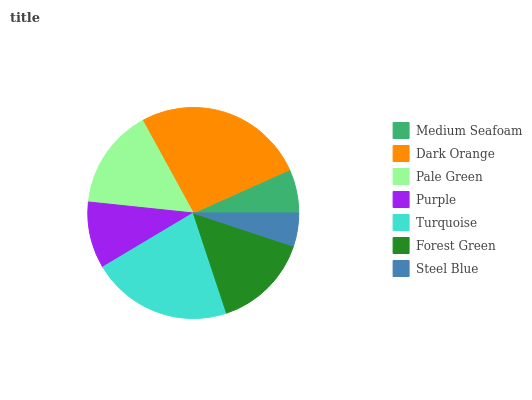Is Steel Blue the minimum?
Answer yes or no. Yes. Is Dark Orange the maximum?
Answer yes or no. Yes. Is Pale Green the minimum?
Answer yes or no. No. Is Pale Green the maximum?
Answer yes or no. No. Is Dark Orange greater than Pale Green?
Answer yes or no. Yes. Is Pale Green less than Dark Orange?
Answer yes or no. Yes. Is Pale Green greater than Dark Orange?
Answer yes or no. No. Is Dark Orange less than Pale Green?
Answer yes or no. No. Is Forest Green the high median?
Answer yes or no. Yes. Is Forest Green the low median?
Answer yes or no. Yes. Is Steel Blue the high median?
Answer yes or no. No. Is Pale Green the low median?
Answer yes or no. No. 